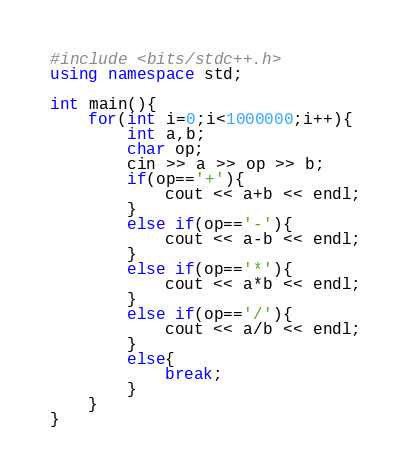Convert code to text. <code><loc_0><loc_0><loc_500><loc_500><_C++_>#include <bits/stdc++.h>
using namespace std;
 
int main(){
    for(int i=0;i<1000000;i++){
        int a,b;
        char op;
        cin >> a >> op >> b;
        if(op=='+'){
            cout << a+b << endl;
        }
        else if(op=='-'){
            cout << a-b << endl;
        }
        else if(op=='*'){
            cout << a*b << endl;
        }
        else if(op=='/'){
            cout << a/b << endl;
        }
        else{
            break;
        }
    }
}
</code> 